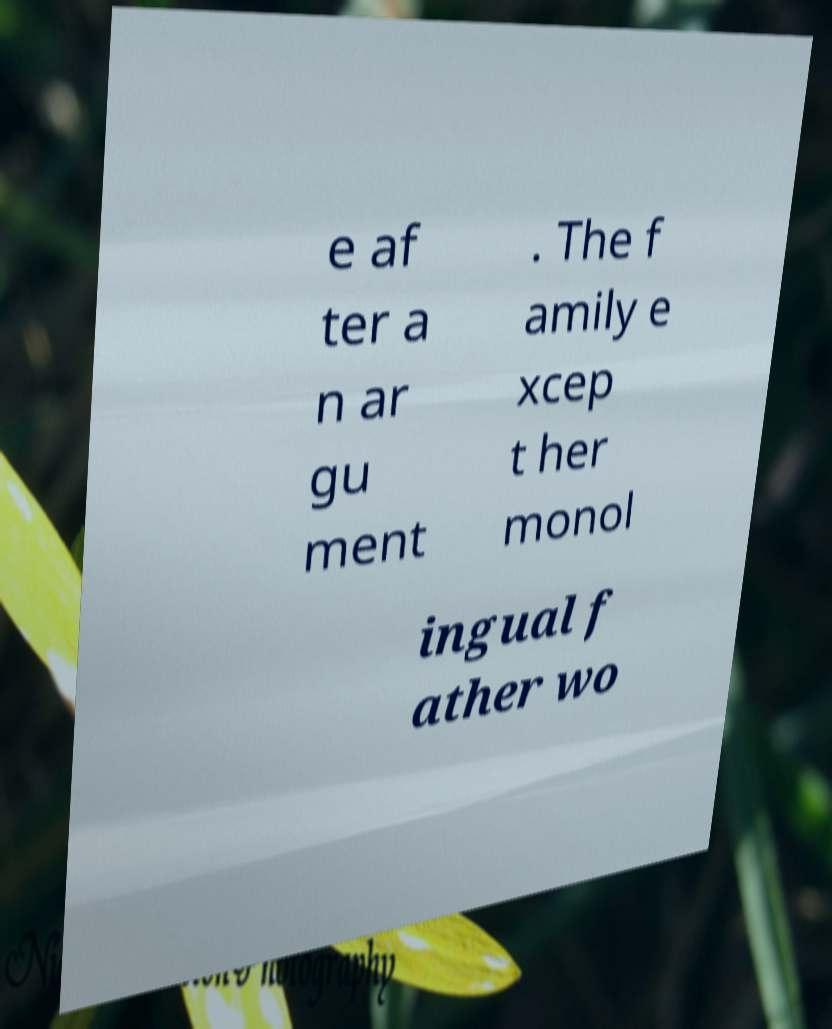Please read and relay the text visible in this image. What does it say? e af ter a n ar gu ment . The f amily e xcep t her monol ingual f ather wo 